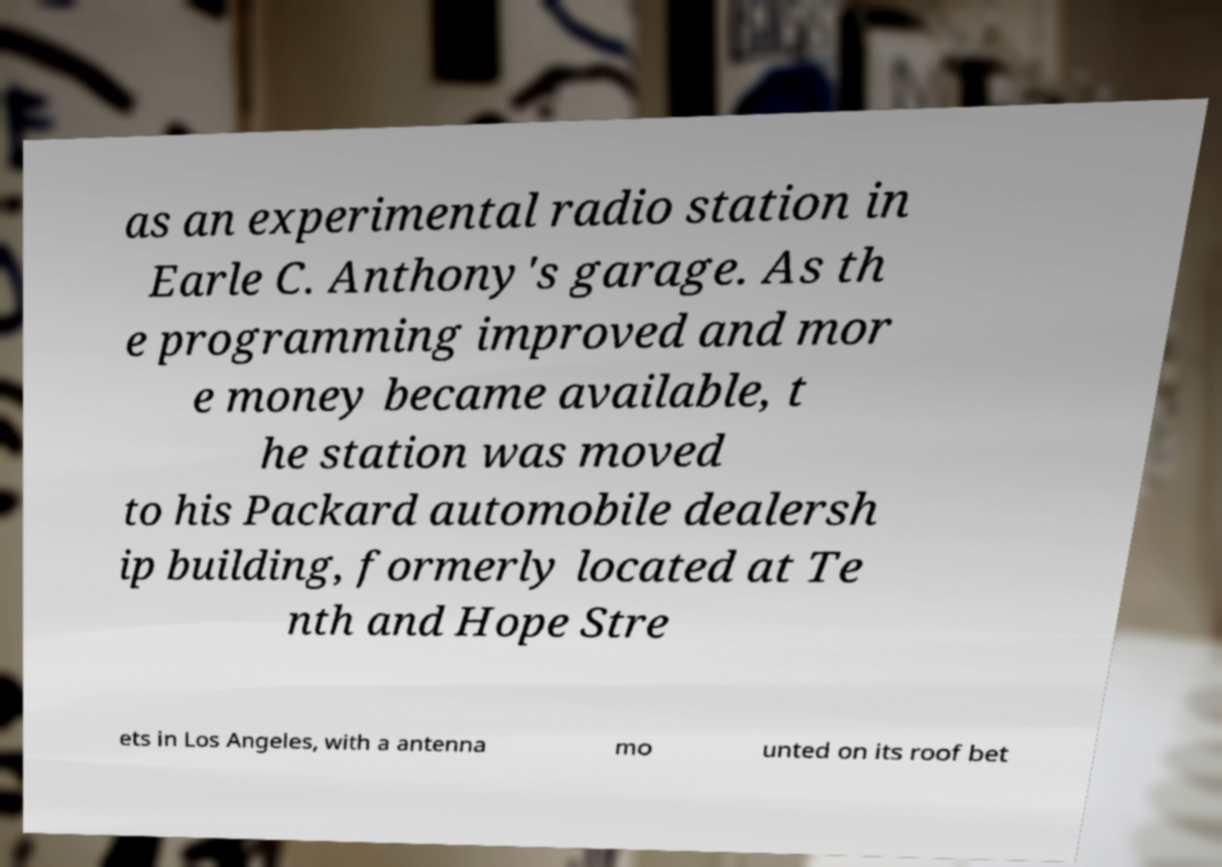Could you assist in decoding the text presented in this image and type it out clearly? as an experimental radio station in Earle C. Anthony's garage. As th e programming improved and mor e money became available, t he station was moved to his Packard automobile dealersh ip building, formerly located at Te nth and Hope Stre ets in Los Angeles, with a antenna mo unted on its roof bet 